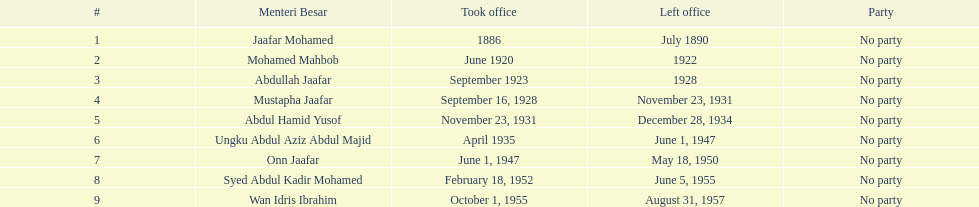Prior to abdullah jaafar, who was in the position? Mohamed Mahbob. 